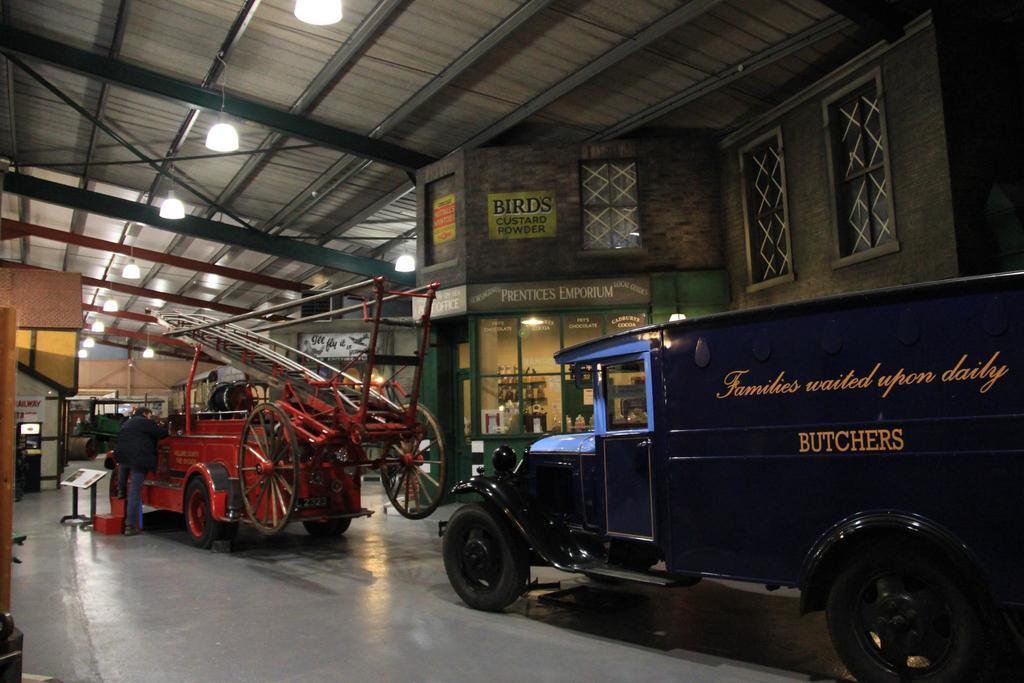Can you describe this image briefly? In this image I can see the ground and two vehicles which are red, black and blue in color on the ground. I can see a ladder on the vehicle. I can see a person standing, the ceiling, few lights to the ceiling, the building, few windows of the building and few other objects. 